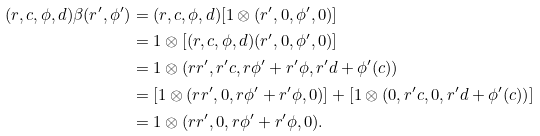<formula> <loc_0><loc_0><loc_500><loc_500>( r , c , \phi , d ) \beta ( r ^ { \prime } , \phi ^ { \prime } ) & = ( r , c , \phi , d ) [ 1 \otimes ( r ^ { \prime } , 0 , \phi ^ { \prime } , 0 ) ] \\ & = 1 \otimes [ ( r , c , \phi , d ) ( r ^ { \prime } , 0 , \phi ^ { \prime } , 0 ) ] \\ & = 1 \otimes ( r r ^ { \prime } , r ^ { \prime } c , r \phi ^ { \prime } + r ^ { \prime } \phi , r ^ { \prime } d + \phi ^ { \prime } ( c ) ) \\ & = [ 1 \otimes ( r r ^ { \prime } , 0 , r \phi ^ { \prime } + r ^ { \prime } \phi , 0 ) ] + [ 1 \otimes ( 0 , r ^ { \prime } c , 0 , r ^ { \prime } d + \phi ^ { \prime } ( c ) ) ] \\ & = 1 \otimes ( r r ^ { \prime } , 0 , r \phi ^ { \prime } + r ^ { \prime } \phi , 0 ) .</formula> 